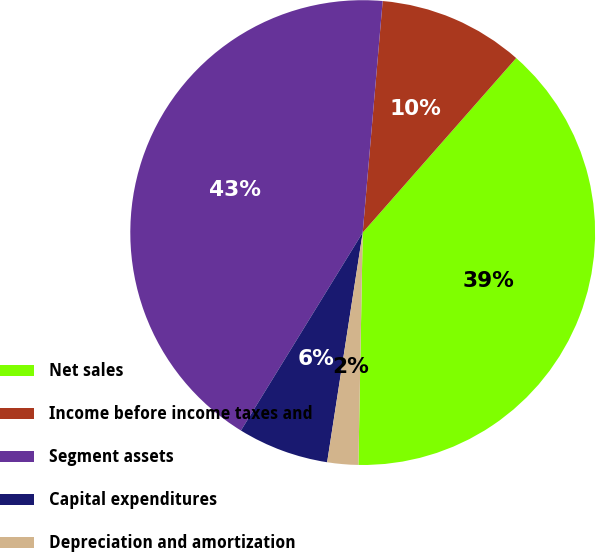Convert chart to OTSL. <chart><loc_0><loc_0><loc_500><loc_500><pie_chart><fcel>Net sales<fcel>Income before income taxes and<fcel>Segment assets<fcel>Capital expenditures<fcel>Depreciation and amortization<nl><fcel>38.81%<fcel>10.11%<fcel>42.59%<fcel>6.33%<fcel>2.15%<nl></chart> 